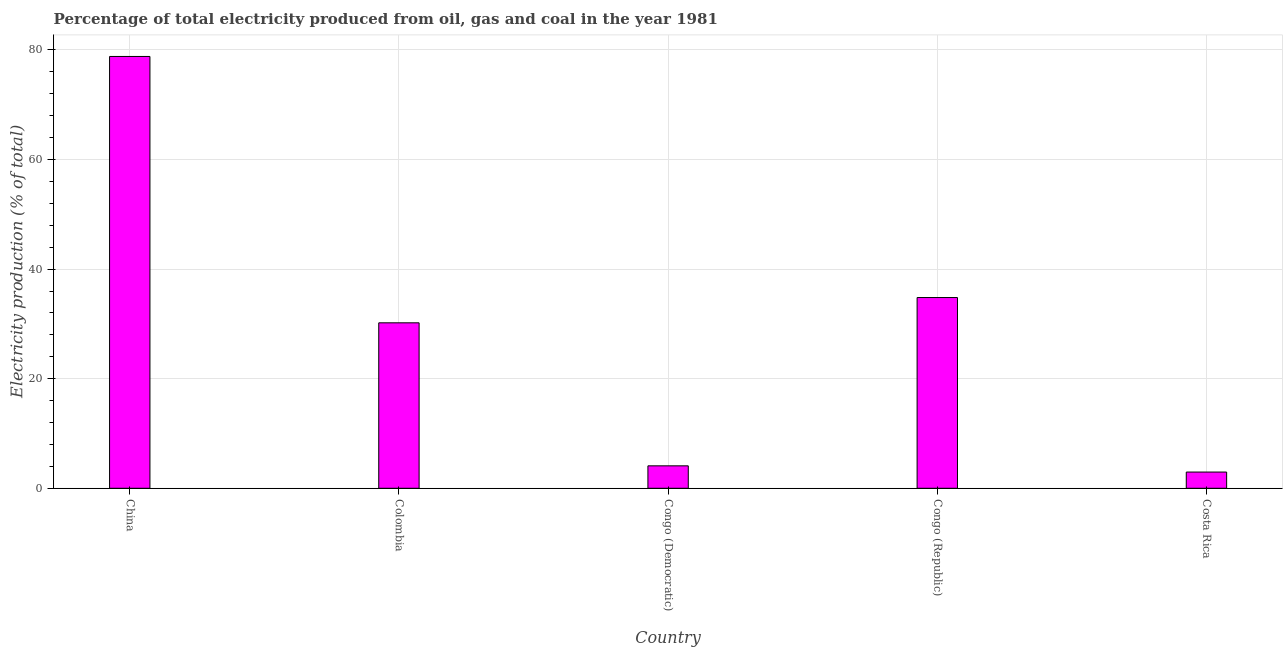What is the title of the graph?
Ensure brevity in your answer.  Percentage of total electricity produced from oil, gas and coal in the year 1981. What is the label or title of the Y-axis?
Offer a terse response. Electricity production (% of total). What is the electricity production in Colombia?
Make the answer very short. 30.2. Across all countries, what is the maximum electricity production?
Your answer should be compact. 78.8. Across all countries, what is the minimum electricity production?
Provide a short and direct response. 2.96. What is the sum of the electricity production?
Keep it short and to the point. 150.87. What is the difference between the electricity production in Colombia and Congo (Democratic)?
Your answer should be very brief. 26.1. What is the average electricity production per country?
Offer a very short reply. 30.17. What is the median electricity production?
Your response must be concise. 30.2. In how many countries, is the electricity production greater than 68 %?
Make the answer very short. 1. What is the ratio of the electricity production in China to that in Colombia?
Make the answer very short. 2.61. Is the electricity production in Congo (Democratic) less than that in Costa Rica?
Provide a short and direct response. No. Is the difference between the electricity production in Colombia and Congo (Republic) greater than the difference between any two countries?
Provide a succinct answer. No. What is the difference between the highest and the second highest electricity production?
Offer a terse response. 43.99. Is the sum of the electricity production in Congo (Democratic) and Costa Rica greater than the maximum electricity production across all countries?
Provide a succinct answer. No. What is the difference between the highest and the lowest electricity production?
Give a very brief answer. 75.85. In how many countries, is the electricity production greater than the average electricity production taken over all countries?
Your response must be concise. 3. Are all the bars in the graph horizontal?
Ensure brevity in your answer.  No. Are the values on the major ticks of Y-axis written in scientific E-notation?
Your answer should be very brief. No. What is the Electricity production (% of total) in China?
Provide a succinct answer. 78.8. What is the Electricity production (% of total) of Colombia?
Your answer should be compact. 30.2. What is the Electricity production (% of total) in Congo (Democratic)?
Your answer should be compact. 4.09. What is the Electricity production (% of total) of Congo (Republic)?
Keep it short and to the point. 34.81. What is the Electricity production (% of total) of Costa Rica?
Provide a succinct answer. 2.96. What is the difference between the Electricity production (% of total) in China and Colombia?
Make the answer very short. 48.61. What is the difference between the Electricity production (% of total) in China and Congo (Democratic)?
Give a very brief answer. 74.71. What is the difference between the Electricity production (% of total) in China and Congo (Republic)?
Offer a very short reply. 43.99. What is the difference between the Electricity production (% of total) in China and Costa Rica?
Ensure brevity in your answer.  75.85. What is the difference between the Electricity production (% of total) in Colombia and Congo (Democratic)?
Give a very brief answer. 26.1. What is the difference between the Electricity production (% of total) in Colombia and Congo (Republic)?
Ensure brevity in your answer.  -4.61. What is the difference between the Electricity production (% of total) in Colombia and Costa Rica?
Keep it short and to the point. 27.24. What is the difference between the Electricity production (% of total) in Congo (Democratic) and Congo (Republic)?
Ensure brevity in your answer.  -30.72. What is the difference between the Electricity production (% of total) in Congo (Democratic) and Costa Rica?
Provide a short and direct response. 1.13. What is the difference between the Electricity production (% of total) in Congo (Republic) and Costa Rica?
Offer a very short reply. 31.85. What is the ratio of the Electricity production (% of total) in China to that in Colombia?
Your response must be concise. 2.61. What is the ratio of the Electricity production (% of total) in China to that in Congo (Democratic)?
Offer a very short reply. 19.25. What is the ratio of the Electricity production (% of total) in China to that in Congo (Republic)?
Provide a succinct answer. 2.26. What is the ratio of the Electricity production (% of total) in China to that in Costa Rica?
Provide a short and direct response. 26.62. What is the ratio of the Electricity production (% of total) in Colombia to that in Congo (Democratic)?
Give a very brief answer. 7.37. What is the ratio of the Electricity production (% of total) in Colombia to that in Congo (Republic)?
Offer a very short reply. 0.87. What is the ratio of the Electricity production (% of total) in Colombia to that in Costa Rica?
Give a very brief answer. 10.2. What is the ratio of the Electricity production (% of total) in Congo (Democratic) to that in Congo (Republic)?
Your answer should be very brief. 0.12. What is the ratio of the Electricity production (% of total) in Congo (Democratic) to that in Costa Rica?
Give a very brief answer. 1.38. What is the ratio of the Electricity production (% of total) in Congo (Republic) to that in Costa Rica?
Offer a very short reply. 11.76. 